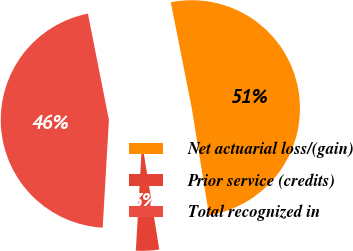Convert chart. <chart><loc_0><loc_0><loc_500><loc_500><pie_chart><fcel>Net actuarial loss/(gain)<fcel>Prior service (credits)<fcel>Total recognized in<nl><fcel>50.57%<fcel>3.46%<fcel>45.97%<nl></chart> 